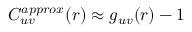Convert formula to latex. <formula><loc_0><loc_0><loc_500><loc_500>C _ { u v } ^ { a p p r o x } ( r ) \approx g _ { u v } ( r ) - 1</formula> 